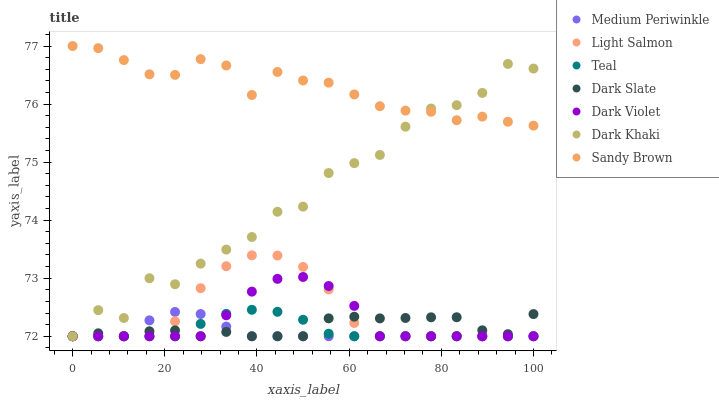Does Medium Periwinkle have the minimum area under the curve?
Answer yes or no. Yes. Does Sandy Brown have the maximum area under the curve?
Answer yes or no. Yes. Does Dark Violet have the minimum area under the curve?
Answer yes or no. No. Does Dark Violet have the maximum area under the curve?
Answer yes or no. No. Is Teal the smoothest?
Answer yes or no. Yes. Is Dark Khaki the roughest?
Answer yes or no. Yes. Is Medium Periwinkle the smoothest?
Answer yes or no. No. Is Medium Periwinkle the roughest?
Answer yes or no. No. Does Light Salmon have the lowest value?
Answer yes or no. Yes. Does Sandy Brown have the lowest value?
Answer yes or no. No. Does Sandy Brown have the highest value?
Answer yes or no. Yes. Does Medium Periwinkle have the highest value?
Answer yes or no. No. Is Medium Periwinkle less than Sandy Brown?
Answer yes or no. Yes. Is Sandy Brown greater than Dark Violet?
Answer yes or no. Yes. Does Dark Khaki intersect Teal?
Answer yes or no. Yes. Is Dark Khaki less than Teal?
Answer yes or no. No. Is Dark Khaki greater than Teal?
Answer yes or no. No. Does Medium Periwinkle intersect Sandy Brown?
Answer yes or no. No. 